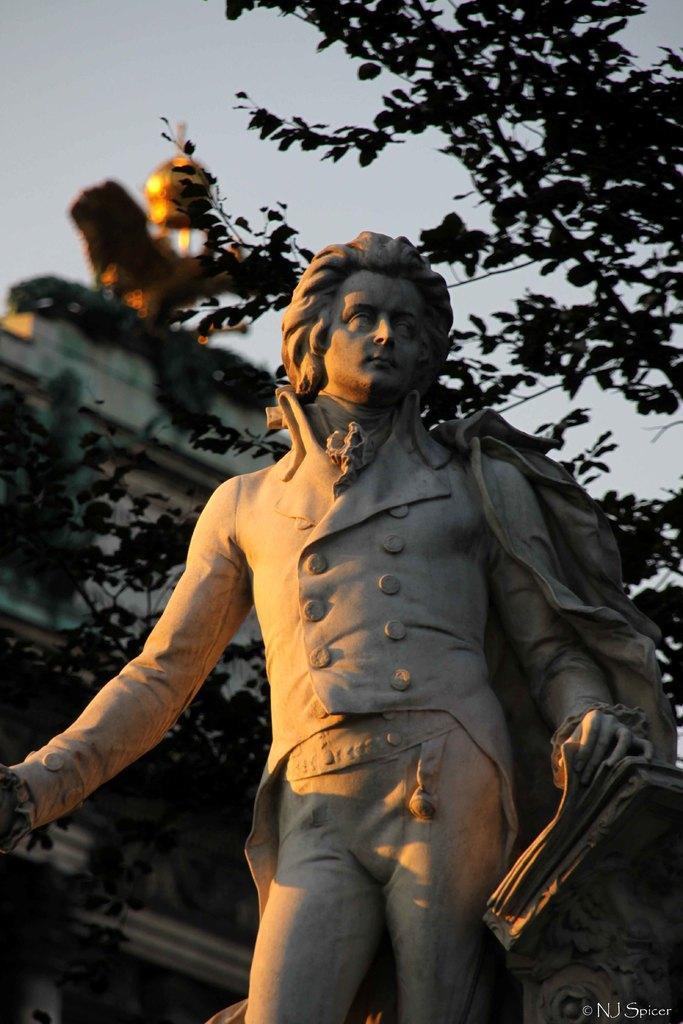Please provide a concise description of this image. In the center of the image we can see a statue. On the backside we can see a building, branches of a tree and the sky which looks cloudy. 